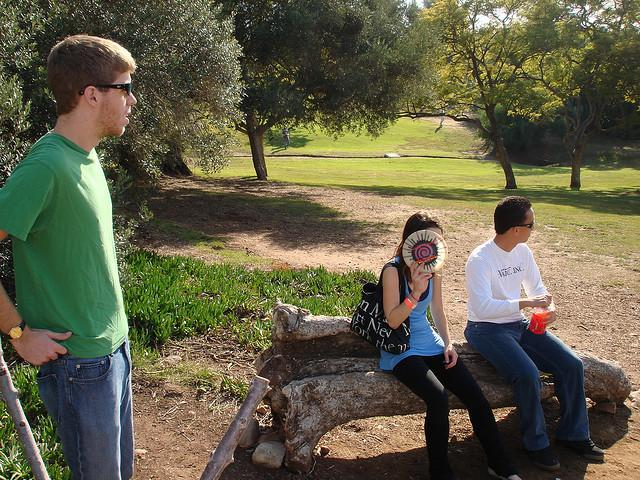Why is she holding up the item? cover face 